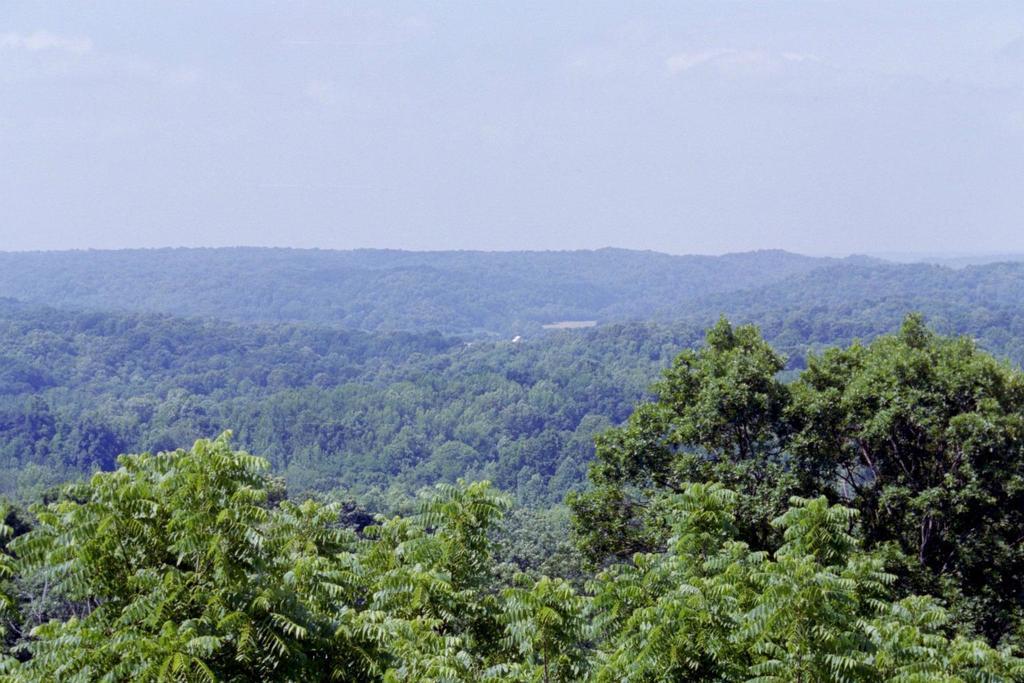Could you give a brief overview of what you see in this image? In this image I can see trees and mountains. On the top I can see the sky. This image is taken may be in the forest. 